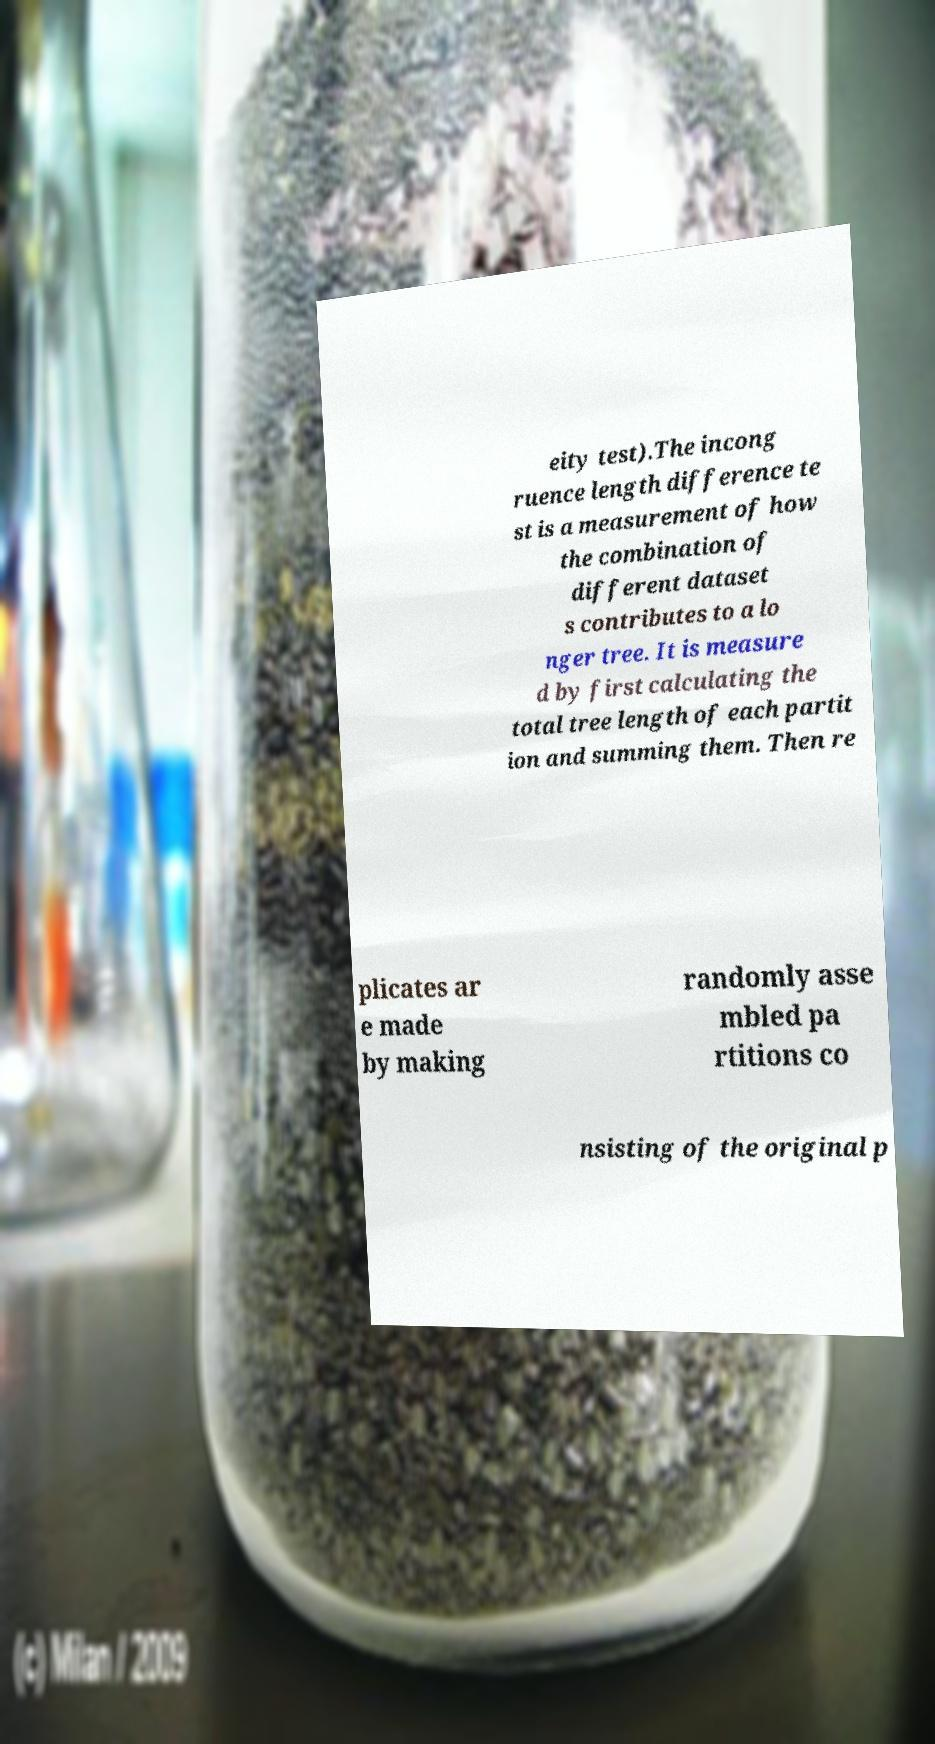Can you accurately transcribe the text from the provided image for me? eity test).The incong ruence length difference te st is a measurement of how the combination of different dataset s contributes to a lo nger tree. It is measure d by first calculating the total tree length of each partit ion and summing them. Then re plicates ar e made by making randomly asse mbled pa rtitions co nsisting of the original p 